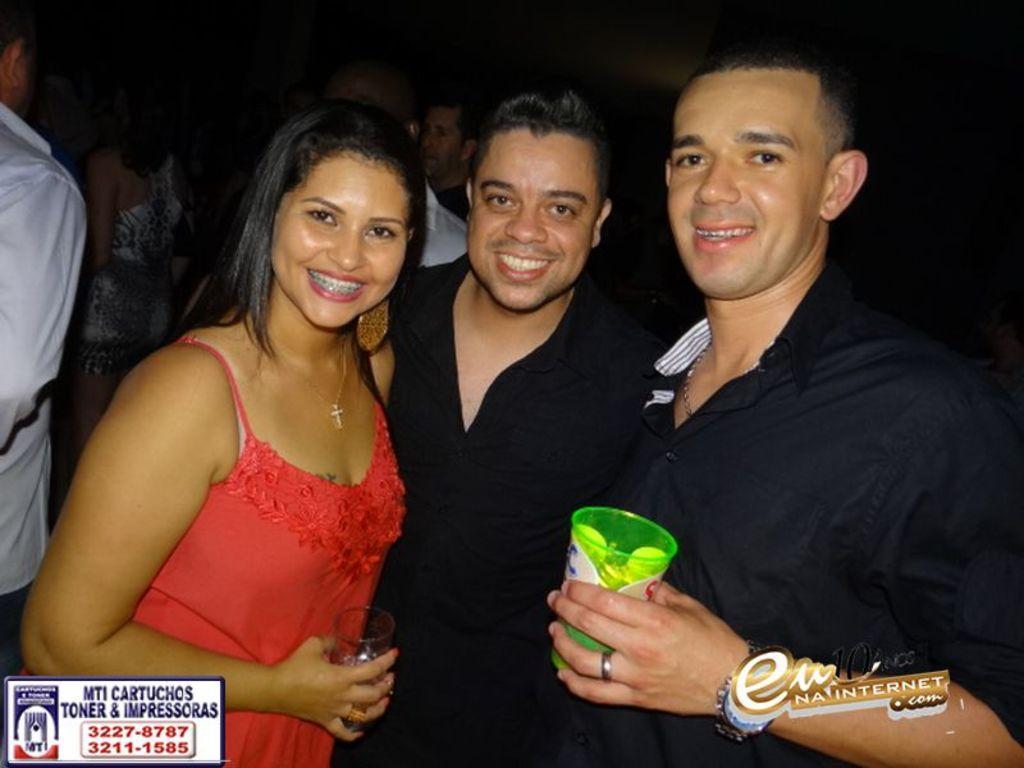In one or two sentences, can you explain what this image depicts? In this image I can see on the left side a beautiful woman is smiling and also holding the wine glass in her hand. Beside her a man is smiling, on the right side a man is holding the glass. He wore black color shirt. 